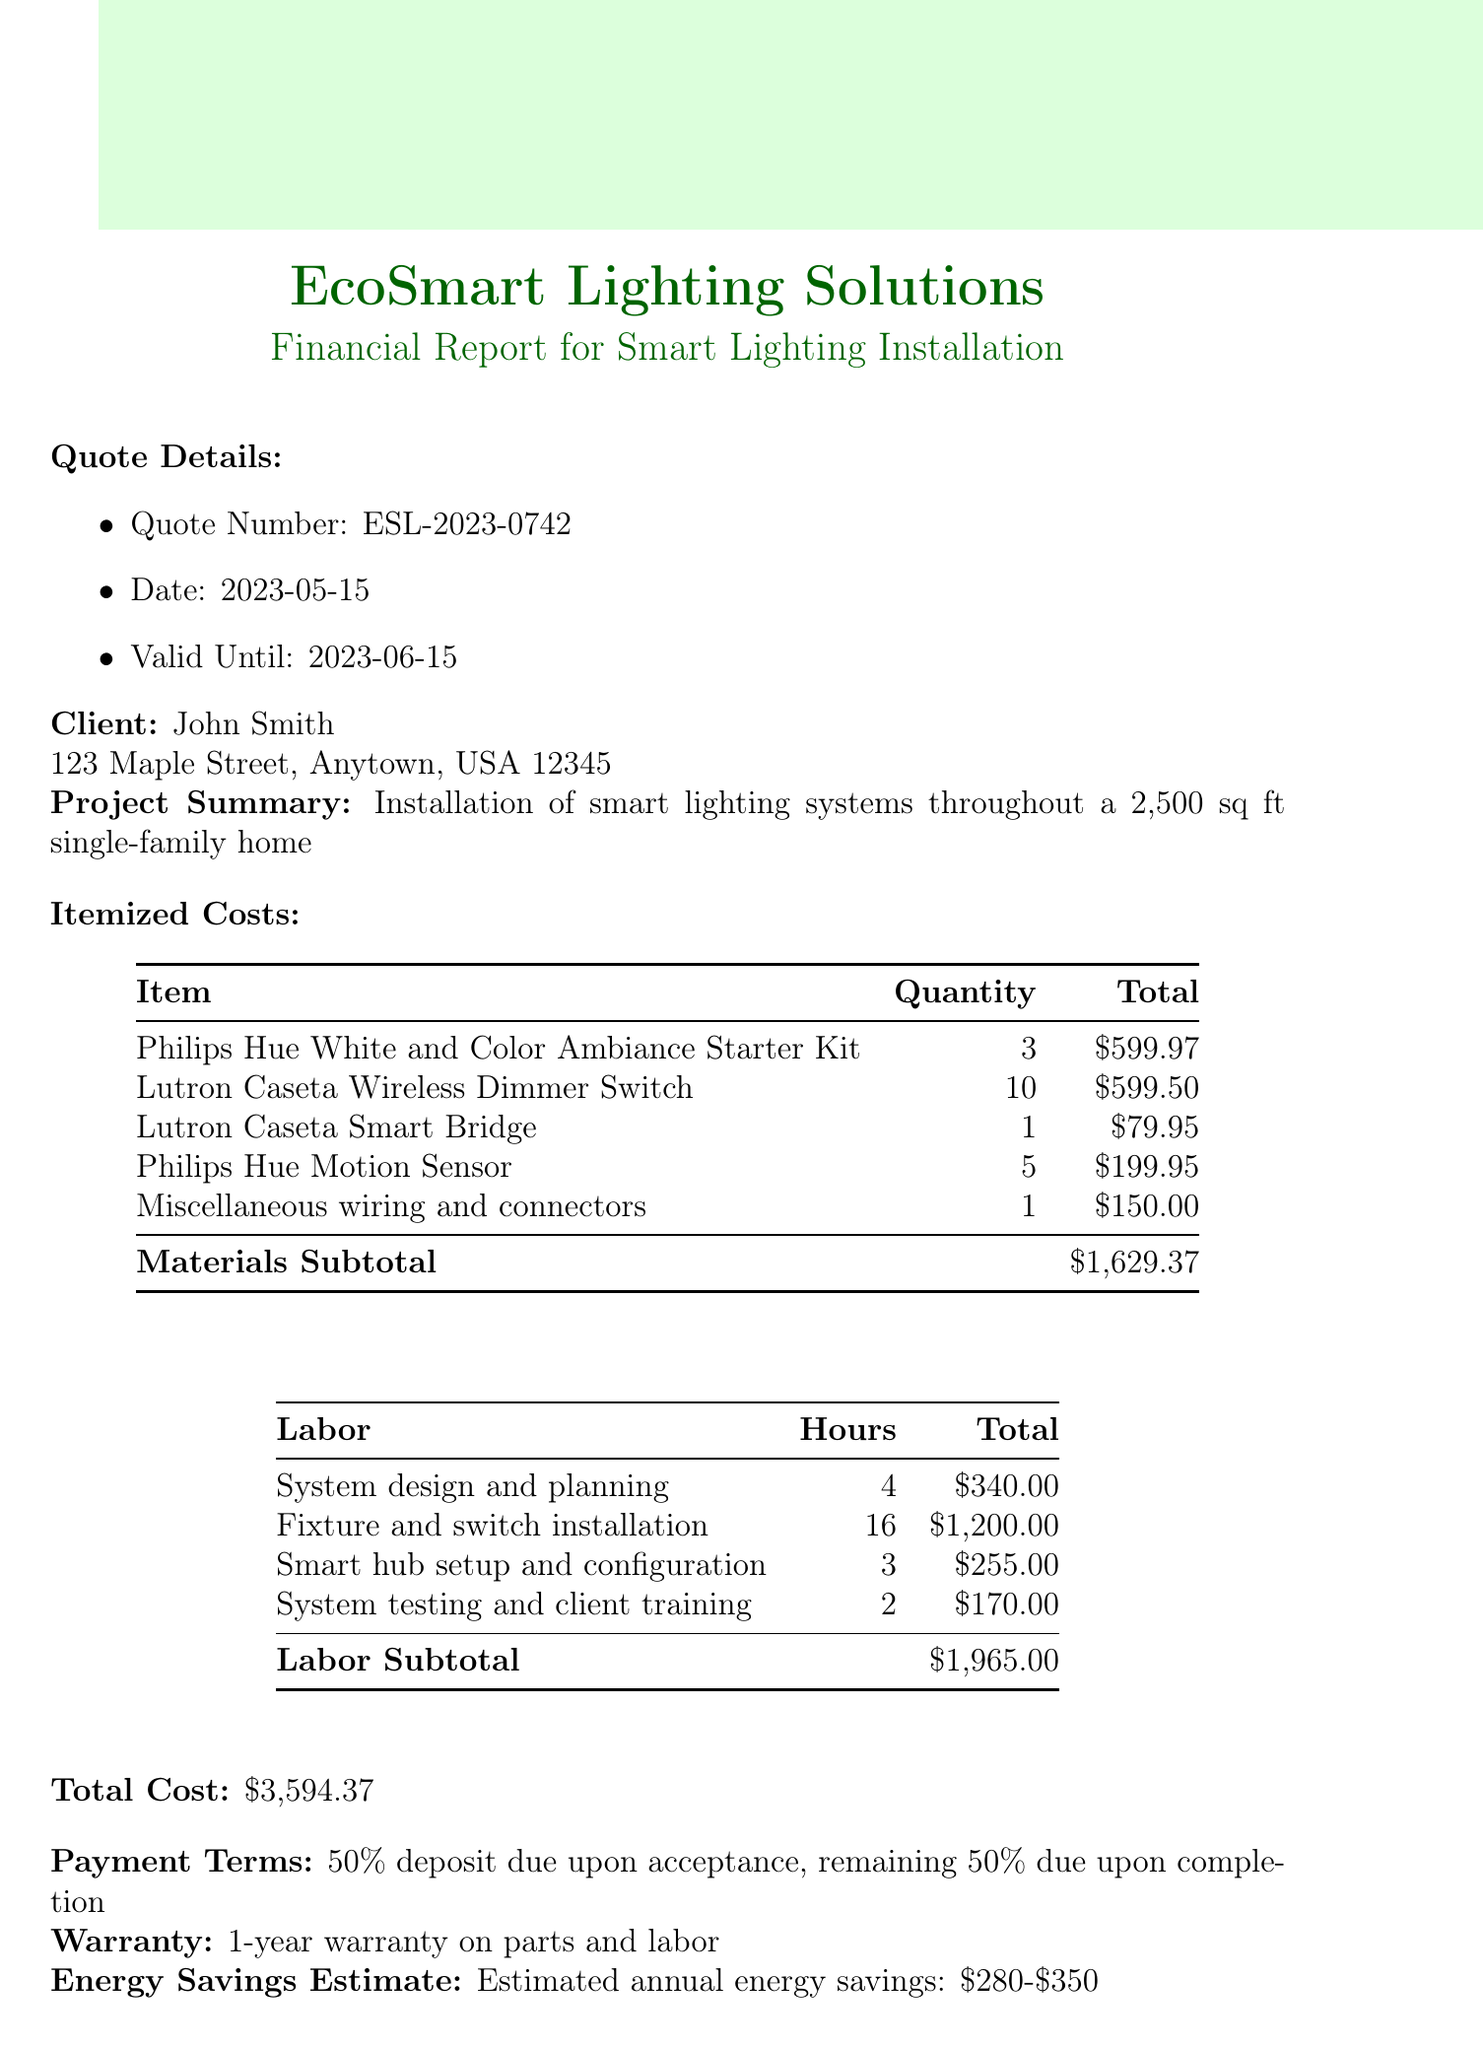What is the quote number? The quote number is listed in the quote details section of the document.
Answer: ESL-2023-0742 Who is the client? The document includes the client's name in the client information section.
Answer: John Smith What is the total cost of the project? The total cost is calculated from the sum of materials and labor costs.
Answer: $3,594.37 What is the subtotal for materials? The subtotal for materials is detailed under itemized costs in the document.
Answer: $1,629.37 How many Philips Hue White and Color Ambiance Starter Kits are included? The quantity of each item is specified in the itemized costs section.
Answer: 3 What is the hourly rate for labor? The hourly rate can be found within the labor cost calculations in the document.
Answer: $85.00 What is the warranty period? The warranty information is clearly stated in the last section of the document.
Answer: 1-year warranty What are the payment terms? The payment terms are provided in the financial report under a specific section.
Answer: 50% deposit due upon acceptance, remaining 50% due upon completion What type of lighting system is being installed? The project summary describes the type of installation being performed.
Answer: Smart lighting systems 